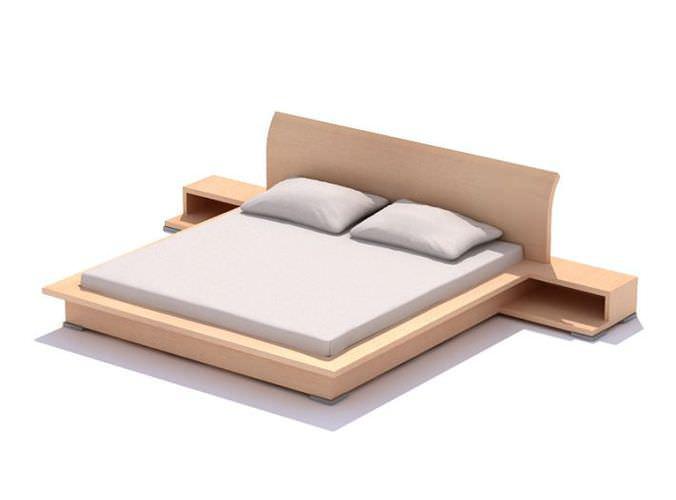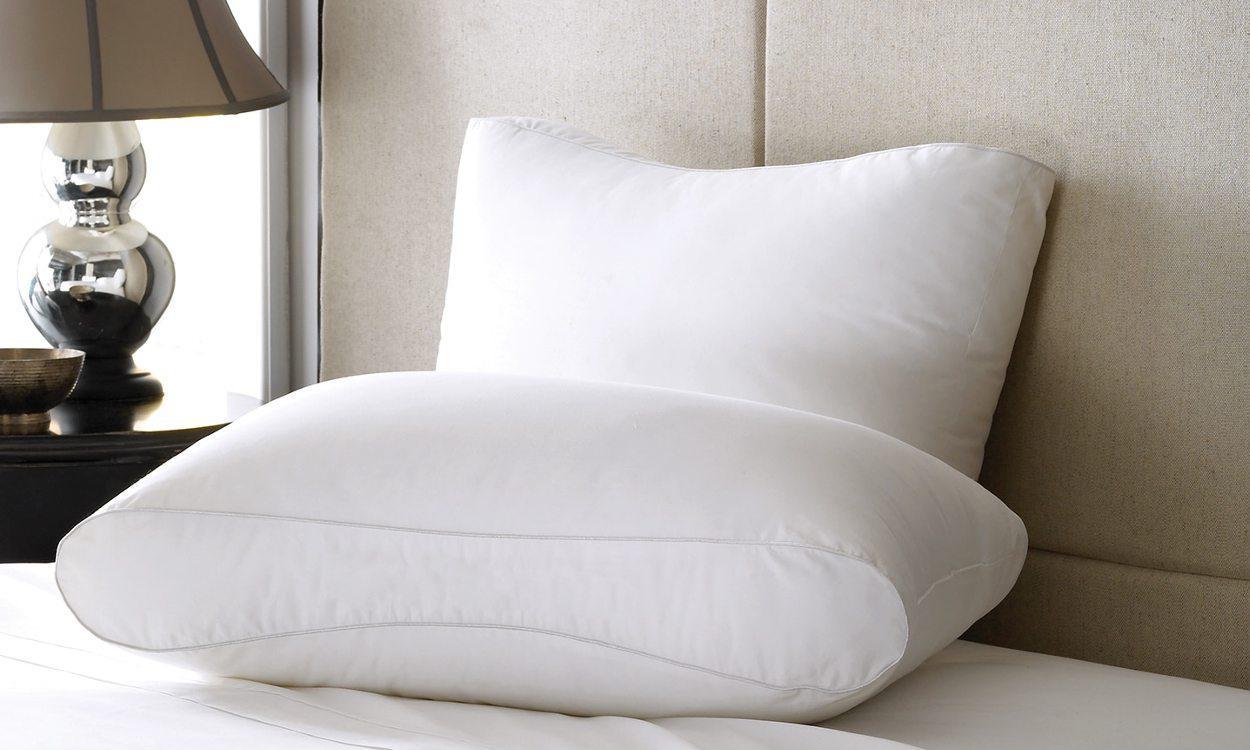The first image is the image on the left, the second image is the image on the right. Evaluate the accuracy of this statement regarding the images: "The left and right image contains the same number of pillow place on the bed.". Is it true? Answer yes or no. Yes. The first image is the image on the left, the second image is the image on the right. Examine the images to the left and right. Is the description "The right image shows pillows on a sofa-shaped dark bed that is angled facing rightward." accurate? Answer yes or no. No. 